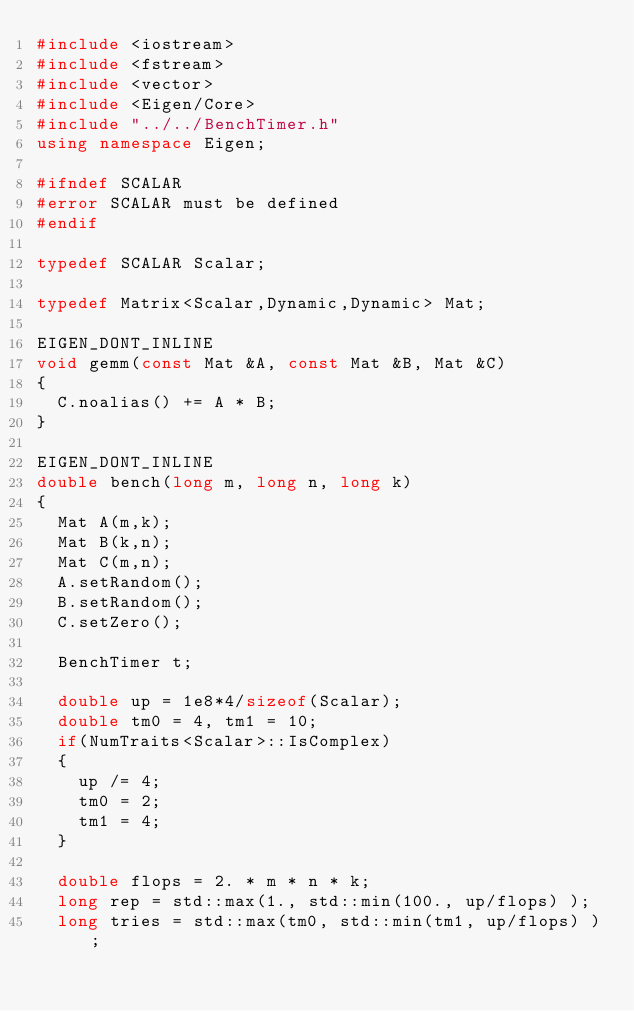<code> <loc_0><loc_0><loc_500><loc_500><_C++_>#include <iostream>
#include <fstream>
#include <vector>
#include <Eigen/Core>
#include "../../BenchTimer.h"
using namespace Eigen;

#ifndef SCALAR
#error SCALAR must be defined
#endif

typedef SCALAR Scalar;

typedef Matrix<Scalar,Dynamic,Dynamic> Mat;

EIGEN_DONT_INLINE
void gemm(const Mat &A, const Mat &B, Mat &C)
{
  C.noalias() += A * B;
}

EIGEN_DONT_INLINE
double bench(long m, long n, long k)
{
  Mat A(m,k);
  Mat B(k,n);
  Mat C(m,n);
  A.setRandom();
  B.setRandom();
  C.setZero();
  
  BenchTimer t;
  
  double up = 1e8*4/sizeof(Scalar);
  double tm0 = 4, tm1 = 10;
  if(NumTraits<Scalar>::IsComplex)
  {
    up /= 4;
    tm0 = 2;
    tm1 = 4;
  }
  
  double flops = 2. * m * n * k;
  long rep = std::max(1., std::min(100., up/flops) );
  long tries = std::max(tm0, std::min(tm1, up/flops) );
  </code> 